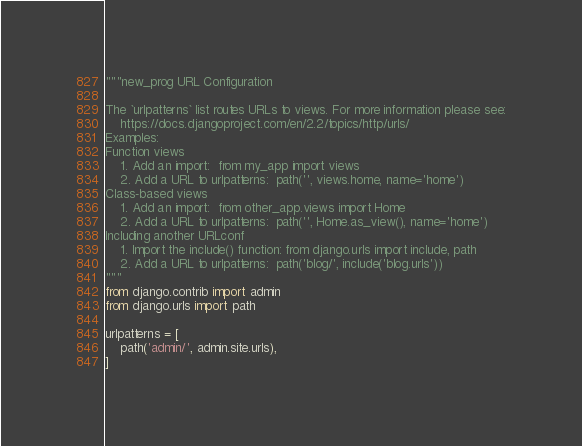<code> <loc_0><loc_0><loc_500><loc_500><_Python_>"""new_prog URL Configuration

The `urlpatterns` list routes URLs to views. For more information please see:
    https://docs.djangoproject.com/en/2.2/topics/http/urls/
Examples:
Function views
    1. Add an import:  from my_app import views
    2. Add a URL to urlpatterns:  path('', views.home, name='home')
Class-based views
    1. Add an import:  from other_app.views import Home
    2. Add a URL to urlpatterns:  path('', Home.as_view(), name='home')
Including another URLconf
    1. Import the include() function: from django.urls import include, path
    2. Add a URL to urlpatterns:  path('blog/', include('blog.urls'))
"""
from django.contrib import admin
from django.urls import path

urlpatterns = [
    path('admin/', admin.site.urls),
]
</code> 